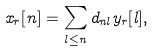<formula> <loc_0><loc_0><loc_500><loc_500>x _ { r } [ n ] = \sum _ { l \leq n } d _ { n l } y _ { r } [ l ] ,</formula> 